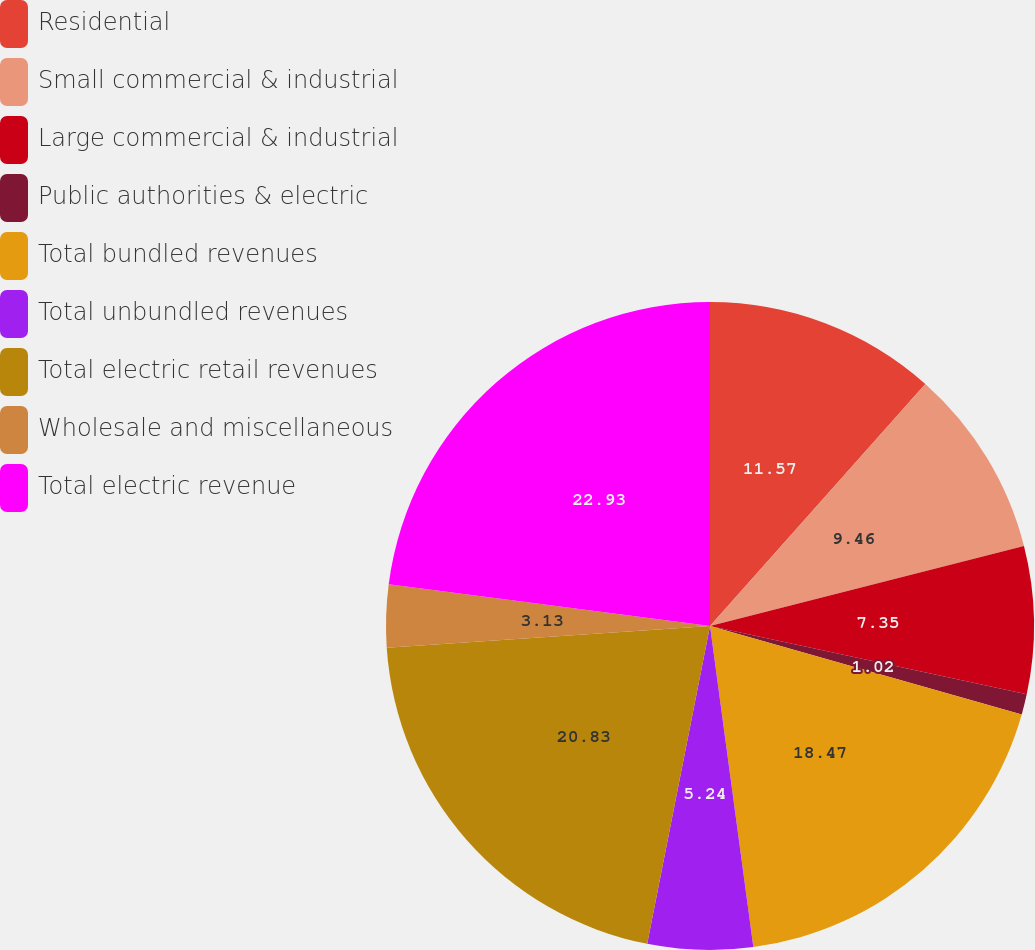Convert chart. <chart><loc_0><loc_0><loc_500><loc_500><pie_chart><fcel>Residential<fcel>Small commercial & industrial<fcel>Large commercial & industrial<fcel>Public authorities & electric<fcel>Total bundled revenues<fcel>Total unbundled revenues<fcel>Total electric retail revenues<fcel>Wholesale and miscellaneous<fcel>Total electric revenue<nl><fcel>11.57%<fcel>9.46%<fcel>7.35%<fcel>1.02%<fcel>18.47%<fcel>5.24%<fcel>20.83%<fcel>3.13%<fcel>22.94%<nl></chart> 